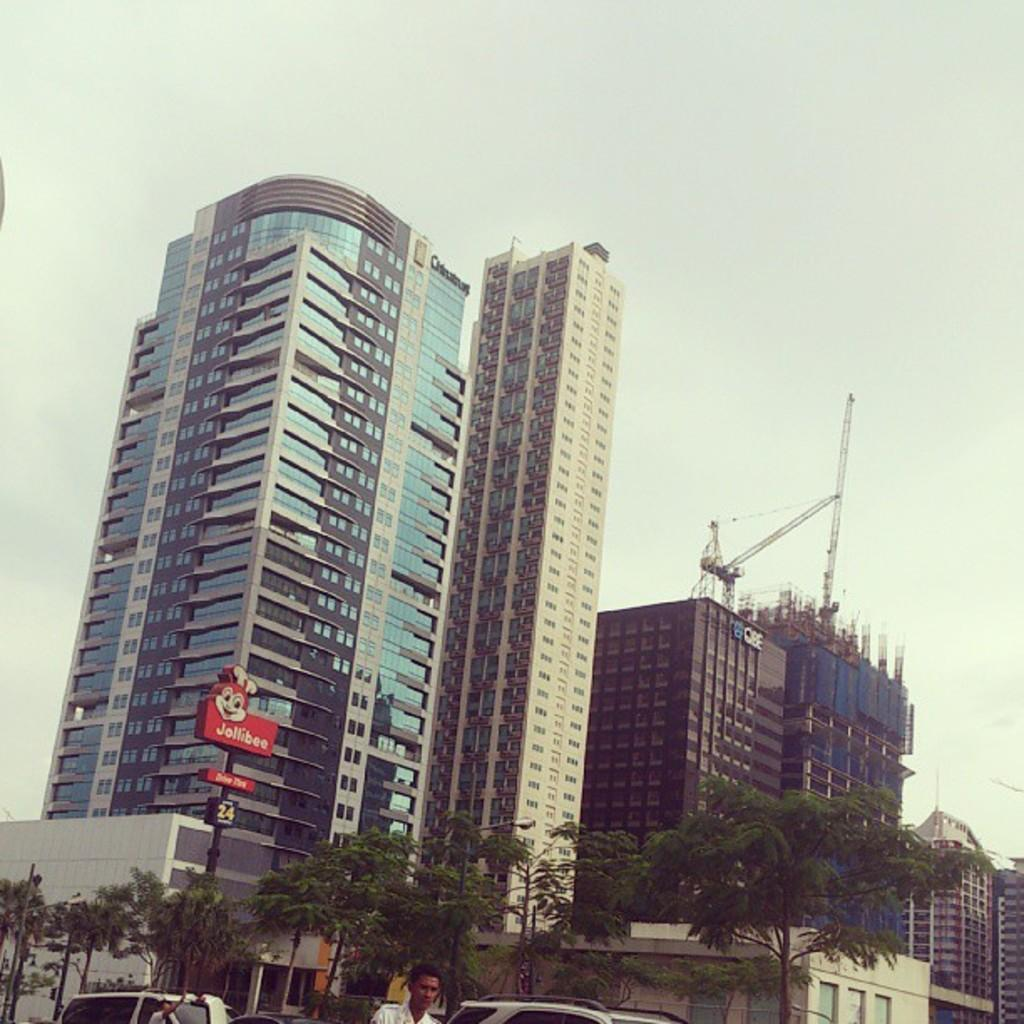What type of structure is located on the left side of the image? There is a skyscraper on the left side of the image. What can be seen on the right side of the image? There are buildings on the right side of the image. What type of vegetation is at the bottom side of the image? There are trees at the bottom side of the image. Where is the wax sculpture of women located in the image? There is no wax sculpture of women present in the image. What type of harbor can be seen in the image? There is no harbor present in the image. 